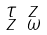Convert formula to latex. <formula><loc_0><loc_0><loc_500><loc_500>\begin{smallmatrix} \tau & z \\ z & \omega \end{smallmatrix}</formula> 